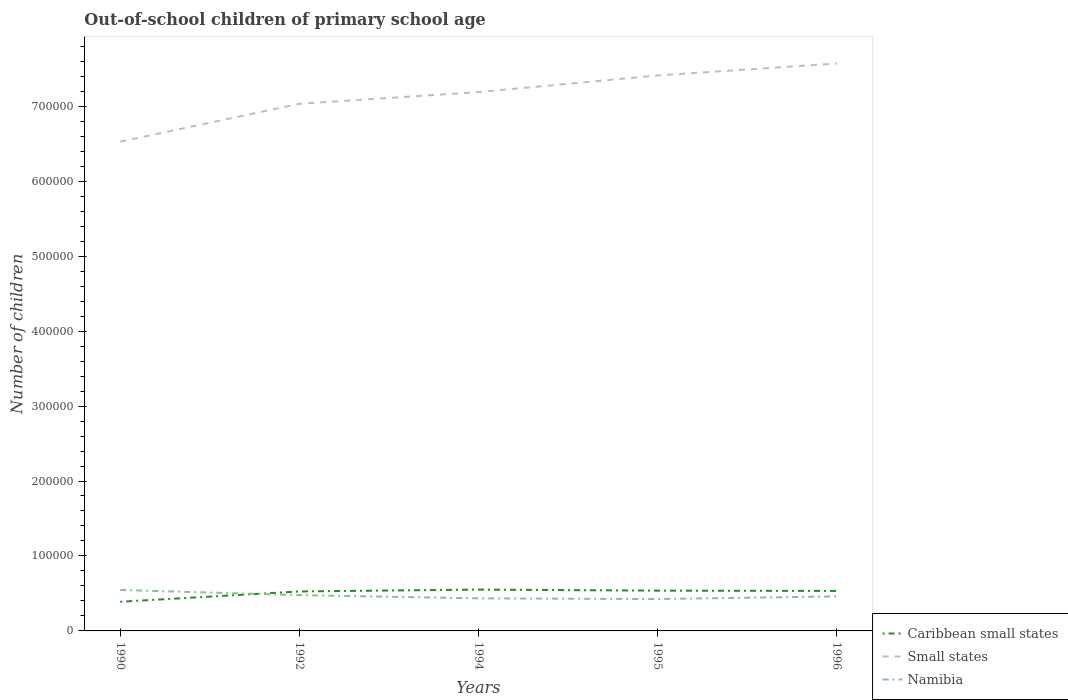Does the line corresponding to Small states intersect with the line corresponding to Namibia?
Your response must be concise. No. Across all years, what is the maximum number of out-of-school children in Small states?
Offer a terse response. 6.53e+05. In which year was the number of out-of-school children in Small states maximum?
Give a very brief answer. 1990. What is the total number of out-of-school children in Caribbean small states in the graph?
Your answer should be compact. -682. What is the difference between the highest and the second highest number of out-of-school children in Caribbean small states?
Offer a very short reply. 1.63e+04. What is the difference between the highest and the lowest number of out-of-school children in Namibia?
Ensure brevity in your answer.  2. Is the number of out-of-school children in Small states strictly greater than the number of out-of-school children in Caribbean small states over the years?
Keep it short and to the point. No. Are the values on the major ticks of Y-axis written in scientific E-notation?
Your answer should be compact. No. Does the graph contain grids?
Make the answer very short. No. Where does the legend appear in the graph?
Give a very brief answer. Bottom right. How many legend labels are there?
Ensure brevity in your answer.  3. What is the title of the graph?
Your response must be concise. Out-of-school children of primary school age. Does "Tonga" appear as one of the legend labels in the graph?
Ensure brevity in your answer.  No. What is the label or title of the X-axis?
Your response must be concise. Years. What is the label or title of the Y-axis?
Your response must be concise. Number of children. What is the Number of children of Caribbean small states in 1990?
Offer a terse response. 3.89e+04. What is the Number of children in Small states in 1990?
Your answer should be very brief. 6.53e+05. What is the Number of children in Namibia in 1990?
Your answer should be very brief. 5.46e+04. What is the Number of children in Caribbean small states in 1992?
Offer a terse response. 5.27e+04. What is the Number of children in Small states in 1992?
Offer a terse response. 7.03e+05. What is the Number of children in Namibia in 1992?
Make the answer very short. 4.78e+04. What is the Number of children in Caribbean small states in 1994?
Ensure brevity in your answer.  5.52e+04. What is the Number of children in Small states in 1994?
Your response must be concise. 7.19e+05. What is the Number of children in Namibia in 1994?
Keep it short and to the point. 4.34e+04. What is the Number of children of Caribbean small states in 1995?
Provide a succinct answer. 5.38e+04. What is the Number of children of Small states in 1995?
Offer a terse response. 7.41e+05. What is the Number of children of Namibia in 1995?
Offer a terse response. 4.25e+04. What is the Number of children of Caribbean small states in 1996?
Provide a succinct answer. 5.33e+04. What is the Number of children in Small states in 1996?
Provide a short and direct response. 7.57e+05. What is the Number of children of Namibia in 1996?
Provide a short and direct response. 4.61e+04. Across all years, what is the maximum Number of children in Caribbean small states?
Provide a succinct answer. 5.52e+04. Across all years, what is the maximum Number of children of Small states?
Provide a short and direct response. 7.57e+05. Across all years, what is the maximum Number of children in Namibia?
Offer a terse response. 5.46e+04. Across all years, what is the minimum Number of children of Caribbean small states?
Provide a succinct answer. 3.89e+04. Across all years, what is the minimum Number of children of Small states?
Your answer should be very brief. 6.53e+05. Across all years, what is the minimum Number of children of Namibia?
Your answer should be compact. 4.25e+04. What is the total Number of children in Caribbean small states in the graph?
Ensure brevity in your answer.  2.54e+05. What is the total Number of children in Small states in the graph?
Offer a terse response. 3.57e+06. What is the total Number of children of Namibia in the graph?
Your answer should be very brief. 2.34e+05. What is the difference between the Number of children in Caribbean small states in 1990 and that in 1992?
Keep it short and to the point. -1.38e+04. What is the difference between the Number of children in Small states in 1990 and that in 1992?
Give a very brief answer. -5.06e+04. What is the difference between the Number of children of Namibia in 1990 and that in 1992?
Offer a terse response. 6881. What is the difference between the Number of children of Caribbean small states in 1990 and that in 1994?
Your answer should be very brief. -1.63e+04. What is the difference between the Number of children of Small states in 1990 and that in 1994?
Offer a very short reply. -6.62e+04. What is the difference between the Number of children in Namibia in 1990 and that in 1994?
Keep it short and to the point. 1.12e+04. What is the difference between the Number of children of Caribbean small states in 1990 and that in 1995?
Offer a very short reply. -1.49e+04. What is the difference between the Number of children of Small states in 1990 and that in 1995?
Provide a succinct answer. -8.84e+04. What is the difference between the Number of children in Namibia in 1990 and that in 1995?
Give a very brief answer. 1.21e+04. What is the difference between the Number of children in Caribbean small states in 1990 and that in 1996?
Your response must be concise. -1.44e+04. What is the difference between the Number of children in Small states in 1990 and that in 1996?
Provide a short and direct response. -1.04e+05. What is the difference between the Number of children in Namibia in 1990 and that in 1996?
Ensure brevity in your answer.  8555. What is the difference between the Number of children of Caribbean small states in 1992 and that in 1994?
Offer a very short reply. -2501. What is the difference between the Number of children of Small states in 1992 and that in 1994?
Make the answer very short. -1.56e+04. What is the difference between the Number of children in Namibia in 1992 and that in 1994?
Provide a succinct answer. 4336. What is the difference between the Number of children in Caribbean small states in 1992 and that in 1995?
Your answer should be very brief. -1092. What is the difference between the Number of children of Small states in 1992 and that in 1995?
Ensure brevity in your answer.  -3.78e+04. What is the difference between the Number of children of Namibia in 1992 and that in 1995?
Your response must be concise. 5254. What is the difference between the Number of children in Caribbean small states in 1992 and that in 1996?
Ensure brevity in your answer.  -682. What is the difference between the Number of children of Small states in 1992 and that in 1996?
Offer a terse response. -5.38e+04. What is the difference between the Number of children in Namibia in 1992 and that in 1996?
Offer a terse response. 1674. What is the difference between the Number of children of Caribbean small states in 1994 and that in 1995?
Offer a terse response. 1409. What is the difference between the Number of children of Small states in 1994 and that in 1995?
Give a very brief answer. -2.22e+04. What is the difference between the Number of children in Namibia in 1994 and that in 1995?
Keep it short and to the point. 918. What is the difference between the Number of children in Caribbean small states in 1994 and that in 1996?
Your answer should be very brief. 1819. What is the difference between the Number of children in Small states in 1994 and that in 1996?
Ensure brevity in your answer.  -3.81e+04. What is the difference between the Number of children in Namibia in 1994 and that in 1996?
Offer a terse response. -2662. What is the difference between the Number of children of Caribbean small states in 1995 and that in 1996?
Give a very brief answer. 410. What is the difference between the Number of children in Small states in 1995 and that in 1996?
Offer a terse response. -1.60e+04. What is the difference between the Number of children of Namibia in 1995 and that in 1996?
Ensure brevity in your answer.  -3580. What is the difference between the Number of children in Caribbean small states in 1990 and the Number of children in Small states in 1992?
Your response must be concise. -6.64e+05. What is the difference between the Number of children of Caribbean small states in 1990 and the Number of children of Namibia in 1992?
Your response must be concise. -8866. What is the difference between the Number of children of Small states in 1990 and the Number of children of Namibia in 1992?
Offer a terse response. 6.05e+05. What is the difference between the Number of children in Caribbean small states in 1990 and the Number of children in Small states in 1994?
Ensure brevity in your answer.  -6.80e+05. What is the difference between the Number of children in Caribbean small states in 1990 and the Number of children in Namibia in 1994?
Make the answer very short. -4530. What is the difference between the Number of children in Small states in 1990 and the Number of children in Namibia in 1994?
Make the answer very short. 6.09e+05. What is the difference between the Number of children of Caribbean small states in 1990 and the Number of children of Small states in 1995?
Offer a very short reply. -7.02e+05. What is the difference between the Number of children of Caribbean small states in 1990 and the Number of children of Namibia in 1995?
Ensure brevity in your answer.  -3612. What is the difference between the Number of children in Small states in 1990 and the Number of children in Namibia in 1995?
Offer a terse response. 6.10e+05. What is the difference between the Number of children of Caribbean small states in 1990 and the Number of children of Small states in 1996?
Your answer should be compact. -7.18e+05. What is the difference between the Number of children in Caribbean small states in 1990 and the Number of children in Namibia in 1996?
Your answer should be compact. -7192. What is the difference between the Number of children in Small states in 1990 and the Number of children in Namibia in 1996?
Ensure brevity in your answer.  6.07e+05. What is the difference between the Number of children in Caribbean small states in 1992 and the Number of children in Small states in 1994?
Offer a terse response. -6.66e+05. What is the difference between the Number of children of Caribbean small states in 1992 and the Number of children of Namibia in 1994?
Make the answer very short. 9233. What is the difference between the Number of children in Small states in 1992 and the Number of children in Namibia in 1994?
Ensure brevity in your answer.  6.60e+05. What is the difference between the Number of children of Caribbean small states in 1992 and the Number of children of Small states in 1995?
Provide a short and direct response. -6.88e+05. What is the difference between the Number of children in Caribbean small states in 1992 and the Number of children in Namibia in 1995?
Give a very brief answer. 1.02e+04. What is the difference between the Number of children of Small states in 1992 and the Number of children of Namibia in 1995?
Provide a succinct answer. 6.61e+05. What is the difference between the Number of children in Caribbean small states in 1992 and the Number of children in Small states in 1996?
Provide a succinct answer. -7.04e+05. What is the difference between the Number of children in Caribbean small states in 1992 and the Number of children in Namibia in 1996?
Your answer should be very brief. 6571. What is the difference between the Number of children in Small states in 1992 and the Number of children in Namibia in 1996?
Offer a very short reply. 6.57e+05. What is the difference between the Number of children in Caribbean small states in 1994 and the Number of children in Small states in 1995?
Provide a succinct answer. -6.86e+05. What is the difference between the Number of children in Caribbean small states in 1994 and the Number of children in Namibia in 1995?
Your answer should be compact. 1.27e+04. What is the difference between the Number of children in Small states in 1994 and the Number of children in Namibia in 1995?
Make the answer very short. 6.76e+05. What is the difference between the Number of children of Caribbean small states in 1994 and the Number of children of Small states in 1996?
Keep it short and to the point. -7.02e+05. What is the difference between the Number of children in Caribbean small states in 1994 and the Number of children in Namibia in 1996?
Your answer should be compact. 9072. What is the difference between the Number of children in Small states in 1994 and the Number of children in Namibia in 1996?
Your answer should be compact. 6.73e+05. What is the difference between the Number of children in Caribbean small states in 1995 and the Number of children in Small states in 1996?
Make the answer very short. -7.03e+05. What is the difference between the Number of children in Caribbean small states in 1995 and the Number of children in Namibia in 1996?
Offer a terse response. 7663. What is the difference between the Number of children in Small states in 1995 and the Number of children in Namibia in 1996?
Provide a short and direct response. 6.95e+05. What is the average Number of children of Caribbean small states per year?
Provide a succinct answer. 5.08e+04. What is the average Number of children in Small states per year?
Your answer should be compact. 7.15e+05. What is the average Number of children in Namibia per year?
Keep it short and to the point. 4.69e+04. In the year 1990, what is the difference between the Number of children of Caribbean small states and Number of children of Small states?
Give a very brief answer. -6.14e+05. In the year 1990, what is the difference between the Number of children of Caribbean small states and Number of children of Namibia?
Offer a terse response. -1.57e+04. In the year 1990, what is the difference between the Number of children in Small states and Number of children in Namibia?
Your answer should be compact. 5.98e+05. In the year 1992, what is the difference between the Number of children in Caribbean small states and Number of children in Small states?
Your answer should be very brief. -6.51e+05. In the year 1992, what is the difference between the Number of children of Caribbean small states and Number of children of Namibia?
Your response must be concise. 4897. In the year 1992, what is the difference between the Number of children in Small states and Number of children in Namibia?
Your answer should be compact. 6.55e+05. In the year 1994, what is the difference between the Number of children of Caribbean small states and Number of children of Small states?
Offer a very short reply. -6.64e+05. In the year 1994, what is the difference between the Number of children of Caribbean small states and Number of children of Namibia?
Provide a short and direct response. 1.17e+04. In the year 1994, what is the difference between the Number of children of Small states and Number of children of Namibia?
Your response must be concise. 6.75e+05. In the year 1995, what is the difference between the Number of children in Caribbean small states and Number of children in Small states?
Keep it short and to the point. -6.87e+05. In the year 1995, what is the difference between the Number of children in Caribbean small states and Number of children in Namibia?
Provide a succinct answer. 1.12e+04. In the year 1995, what is the difference between the Number of children of Small states and Number of children of Namibia?
Provide a short and direct response. 6.99e+05. In the year 1996, what is the difference between the Number of children of Caribbean small states and Number of children of Small states?
Offer a very short reply. -7.04e+05. In the year 1996, what is the difference between the Number of children in Caribbean small states and Number of children in Namibia?
Provide a short and direct response. 7253. In the year 1996, what is the difference between the Number of children of Small states and Number of children of Namibia?
Give a very brief answer. 7.11e+05. What is the ratio of the Number of children of Caribbean small states in 1990 to that in 1992?
Make the answer very short. 0.74. What is the ratio of the Number of children in Small states in 1990 to that in 1992?
Keep it short and to the point. 0.93. What is the ratio of the Number of children of Namibia in 1990 to that in 1992?
Your answer should be very brief. 1.14. What is the ratio of the Number of children in Caribbean small states in 1990 to that in 1994?
Your answer should be compact. 0.71. What is the ratio of the Number of children in Small states in 1990 to that in 1994?
Offer a terse response. 0.91. What is the ratio of the Number of children in Namibia in 1990 to that in 1994?
Make the answer very short. 1.26. What is the ratio of the Number of children in Caribbean small states in 1990 to that in 1995?
Give a very brief answer. 0.72. What is the ratio of the Number of children in Small states in 1990 to that in 1995?
Provide a succinct answer. 0.88. What is the ratio of the Number of children in Namibia in 1990 to that in 1995?
Provide a succinct answer. 1.29. What is the ratio of the Number of children of Caribbean small states in 1990 to that in 1996?
Make the answer very short. 0.73. What is the ratio of the Number of children of Small states in 1990 to that in 1996?
Provide a succinct answer. 0.86. What is the ratio of the Number of children of Namibia in 1990 to that in 1996?
Your answer should be compact. 1.19. What is the ratio of the Number of children in Caribbean small states in 1992 to that in 1994?
Provide a short and direct response. 0.95. What is the ratio of the Number of children in Small states in 1992 to that in 1994?
Ensure brevity in your answer.  0.98. What is the ratio of the Number of children of Namibia in 1992 to that in 1994?
Provide a short and direct response. 1.1. What is the ratio of the Number of children of Caribbean small states in 1992 to that in 1995?
Provide a succinct answer. 0.98. What is the ratio of the Number of children in Small states in 1992 to that in 1995?
Keep it short and to the point. 0.95. What is the ratio of the Number of children in Namibia in 1992 to that in 1995?
Ensure brevity in your answer.  1.12. What is the ratio of the Number of children of Caribbean small states in 1992 to that in 1996?
Your response must be concise. 0.99. What is the ratio of the Number of children of Small states in 1992 to that in 1996?
Provide a short and direct response. 0.93. What is the ratio of the Number of children of Namibia in 1992 to that in 1996?
Keep it short and to the point. 1.04. What is the ratio of the Number of children of Caribbean small states in 1994 to that in 1995?
Your answer should be very brief. 1.03. What is the ratio of the Number of children in Small states in 1994 to that in 1995?
Give a very brief answer. 0.97. What is the ratio of the Number of children of Namibia in 1994 to that in 1995?
Your answer should be compact. 1.02. What is the ratio of the Number of children in Caribbean small states in 1994 to that in 1996?
Provide a succinct answer. 1.03. What is the ratio of the Number of children of Small states in 1994 to that in 1996?
Make the answer very short. 0.95. What is the ratio of the Number of children of Namibia in 1994 to that in 1996?
Offer a very short reply. 0.94. What is the ratio of the Number of children in Caribbean small states in 1995 to that in 1996?
Your answer should be compact. 1.01. What is the ratio of the Number of children in Small states in 1995 to that in 1996?
Provide a short and direct response. 0.98. What is the ratio of the Number of children in Namibia in 1995 to that in 1996?
Keep it short and to the point. 0.92. What is the difference between the highest and the second highest Number of children in Caribbean small states?
Your response must be concise. 1409. What is the difference between the highest and the second highest Number of children in Small states?
Your answer should be compact. 1.60e+04. What is the difference between the highest and the second highest Number of children of Namibia?
Provide a short and direct response. 6881. What is the difference between the highest and the lowest Number of children in Caribbean small states?
Offer a terse response. 1.63e+04. What is the difference between the highest and the lowest Number of children in Small states?
Provide a succinct answer. 1.04e+05. What is the difference between the highest and the lowest Number of children in Namibia?
Keep it short and to the point. 1.21e+04. 